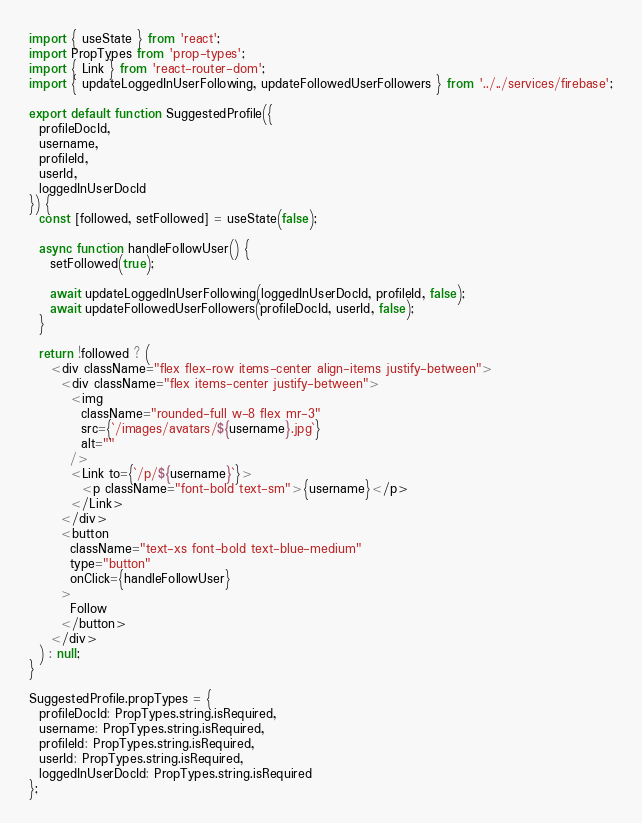<code> <loc_0><loc_0><loc_500><loc_500><_JavaScript_>import { useState } from 'react';
import PropTypes from 'prop-types';
import { Link } from 'react-router-dom';
import { updateLoggedInUserFollowing, updateFollowedUserFollowers } from '../../services/firebase';

export default function SuggestedProfile({
  profileDocId,
  username,
  profileId,
  userId,
  loggedInUserDocId
}) {
  const [followed, setFollowed] = useState(false);

  async function handleFollowUser() {
    setFollowed(true);

    await updateLoggedInUserFollowing(loggedInUserDocId, profileId, false);
    await updateFollowedUserFollowers(profileDocId, userId, false);
  }

  return !followed ? (
    <div className="flex flex-row items-center align-items justify-between">
      <div className="flex items-center justify-between">
        <img
          className="rounded-full w-8 flex mr-3"
          src={`/images/avatars/${username}.jpg`}
          alt=""
        />
        <Link to={`/p/${username}`}>
          <p className="font-bold text-sm">{username}</p>
        </Link>
      </div>
      <button
        className="text-xs font-bold text-blue-medium"
        type="button"
        onClick={handleFollowUser}
      >
        Follow
      </button>
    </div>
  ) : null;
}

SuggestedProfile.propTypes = {
  profileDocId: PropTypes.string.isRequired,
  username: PropTypes.string.isRequired,
  profileId: PropTypes.string.isRequired,
  userId: PropTypes.string.isRequired,
  loggedInUserDocId: PropTypes.string.isRequired
};
</code> 